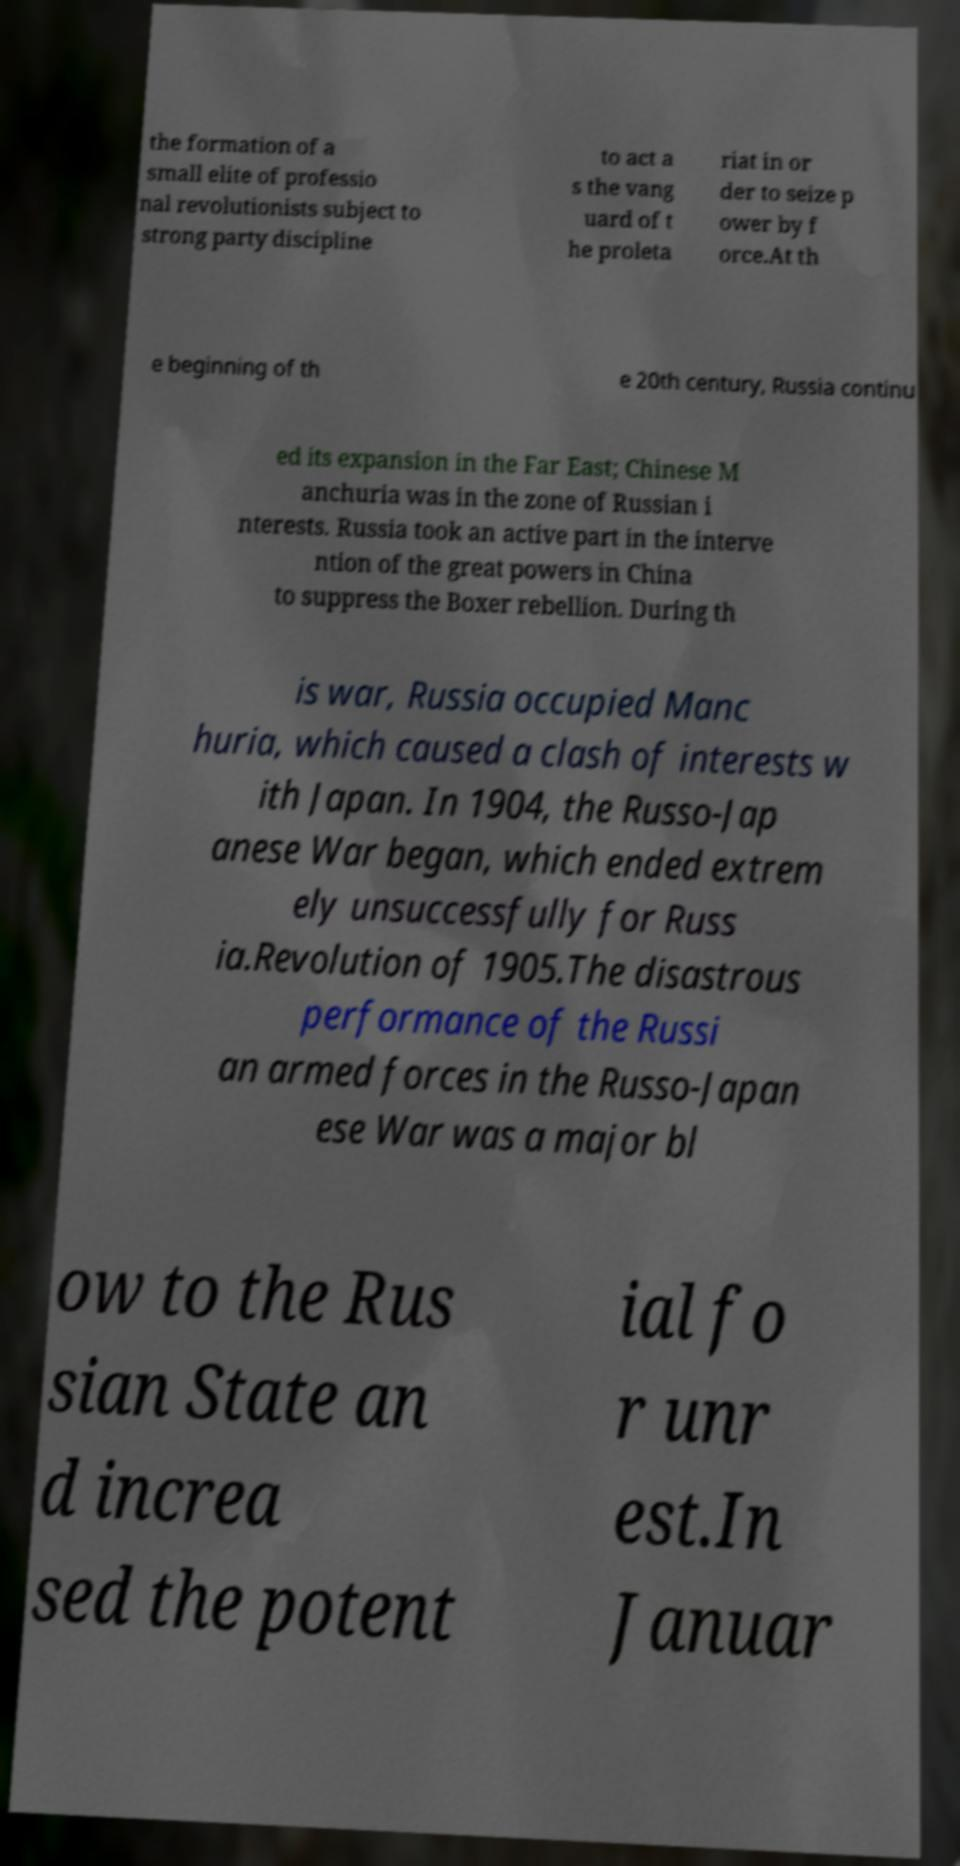Can you accurately transcribe the text from the provided image for me? the formation of a small elite of professio nal revolutionists subject to strong party discipline to act a s the vang uard of t he proleta riat in or der to seize p ower by f orce.At th e beginning of th e 20th century, Russia continu ed its expansion in the Far East; Chinese M anchuria was in the zone of Russian i nterests. Russia took an active part in the interve ntion of the great powers in China to suppress the Boxer rebellion. During th is war, Russia occupied Manc huria, which caused a clash of interests w ith Japan. In 1904, the Russo-Jap anese War began, which ended extrem ely unsuccessfully for Russ ia.Revolution of 1905.The disastrous performance of the Russi an armed forces in the Russo-Japan ese War was a major bl ow to the Rus sian State an d increa sed the potent ial fo r unr est.In Januar 